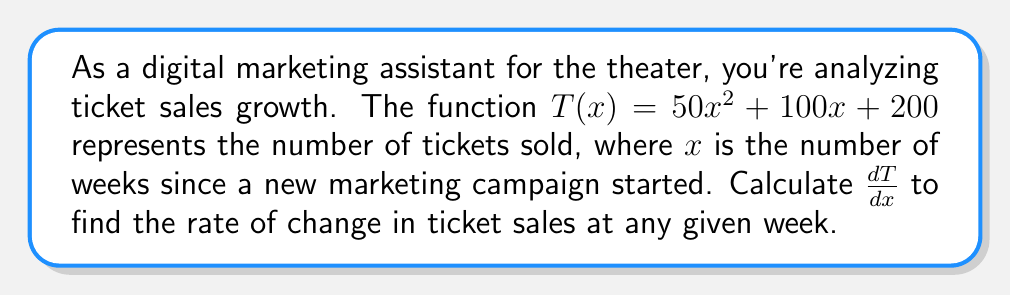Help me with this question. To find the derivative of $T(x)$, we'll use the power rule and the constant rule:

1) For $50x^2$:
   The power rule states that for $ax^n$, the derivative is $nax^{n-1}$.
   Here, $a=50$ and $n=2$.
   So, the derivative of $50x^2$ is $2 \cdot 50x^{2-1} = 100x$.

2) For $100x$:
   This is a linear term, so the derivative is simply the coefficient, 100.

3) For 200:
   The derivative of a constant is 0.

4) Combining these results:
   $\frac{dT}{dx} = 100x + 100 + 0 = 100x + 100$

This derivative represents the instantaneous rate of change in ticket sales with respect to time (in weeks).
Answer: $\frac{dT}{dx} = 100x + 100$ 